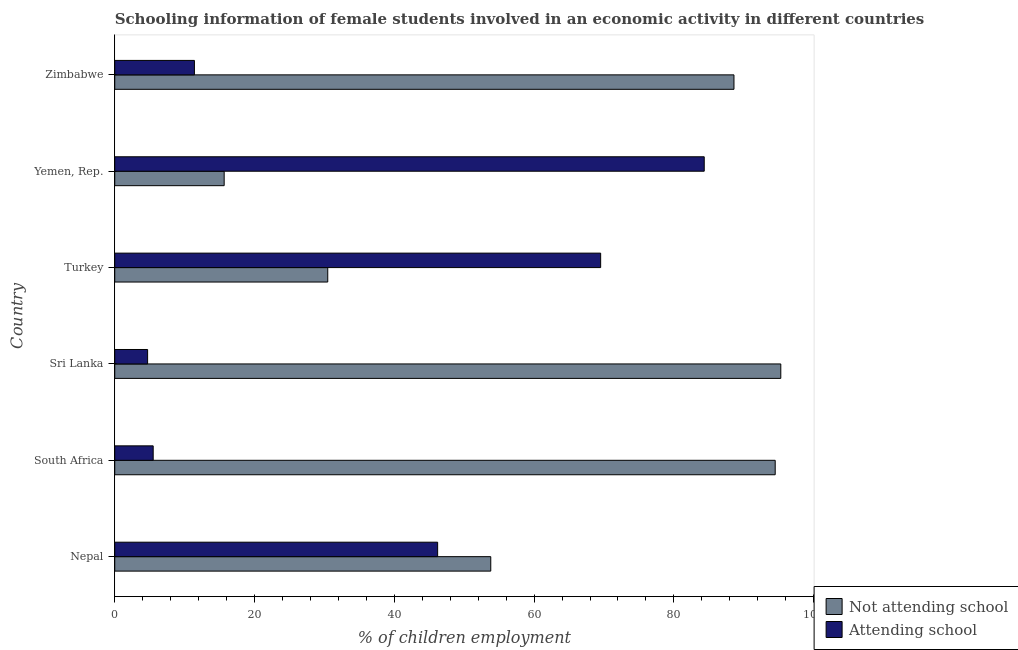Are the number of bars per tick equal to the number of legend labels?
Keep it short and to the point. Yes. How many bars are there on the 4th tick from the top?
Your response must be concise. 2. How many bars are there on the 3rd tick from the bottom?
Your answer should be very brief. 2. What is the label of the 2nd group of bars from the top?
Your response must be concise. Yemen, Rep. In how many cases, is the number of bars for a given country not equal to the number of legend labels?
Offer a very short reply. 0. What is the percentage of employed females who are attending school in Yemen, Rep.?
Your answer should be compact. 84.34. Across all countries, what is the maximum percentage of employed females who are attending school?
Offer a very short reply. 84.34. Across all countries, what is the minimum percentage of employed females who are not attending school?
Your answer should be very brief. 15.66. In which country was the percentage of employed females who are attending school maximum?
Provide a succinct answer. Yemen, Rep. In which country was the percentage of employed females who are not attending school minimum?
Give a very brief answer. Yemen, Rep. What is the total percentage of employed females who are not attending school in the graph?
Make the answer very short. 378.33. What is the difference between the percentage of employed females who are not attending school in Yemen, Rep. and that in Zimbabwe?
Offer a terse response. -72.94. What is the difference between the percentage of employed females who are attending school in Sri Lanka and the percentage of employed females who are not attending school in South Africa?
Ensure brevity in your answer.  -89.8. What is the average percentage of employed females who are attending school per country?
Keep it short and to the point. 36.95. What is the difference between the percentage of employed females who are not attending school and percentage of employed females who are attending school in Yemen, Rep.?
Provide a succinct answer. -68.69. In how many countries, is the percentage of employed females who are attending school greater than 32 %?
Keep it short and to the point. 3. What is the ratio of the percentage of employed females who are not attending school in Nepal to that in Yemen, Rep.?
Keep it short and to the point. 3.44. Is the difference between the percentage of employed females who are attending school in South Africa and Yemen, Rep. greater than the difference between the percentage of employed females who are not attending school in South Africa and Yemen, Rep.?
Keep it short and to the point. No. What is the difference between the highest and the lowest percentage of employed females who are attending school?
Your response must be concise. 79.64. In how many countries, is the percentage of employed females who are attending school greater than the average percentage of employed females who are attending school taken over all countries?
Keep it short and to the point. 3. What does the 2nd bar from the top in Nepal represents?
Ensure brevity in your answer.  Not attending school. What does the 1st bar from the bottom in South Africa represents?
Ensure brevity in your answer.  Not attending school. How many bars are there?
Keep it short and to the point. 12. Are all the bars in the graph horizontal?
Ensure brevity in your answer.  Yes. How many countries are there in the graph?
Your response must be concise. 6. What is the difference between two consecutive major ticks on the X-axis?
Offer a terse response. 20. Are the values on the major ticks of X-axis written in scientific E-notation?
Offer a terse response. No. Does the graph contain any zero values?
Ensure brevity in your answer.  No. How many legend labels are there?
Provide a succinct answer. 2. What is the title of the graph?
Your answer should be compact. Schooling information of female students involved in an economic activity in different countries. Does "External balance on goods" appear as one of the legend labels in the graph?
Your response must be concise. No. What is the label or title of the X-axis?
Make the answer very short. % of children employment. What is the label or title of the Y-axis?
Keep it short and to the point. Country. What is the % of children employment in Not attending school in Nepal?
Keep it short and to the point. 53.8. What is the % of children employment of Attending school in Nepal?
Keep it short and to the point. 46.2. What is the % of children employment in Not attending school in South Africa?
Ensure brevity in your answer.  94.5. What is the % of children employment of Attending school in South Africa?
Make the answer very short. 5.5. What is the % of children employment of Not attending school in Sri Lanka?
Keep it short and to the point. 95.3. What is the % of children employment of Attending school in Sri Lanka?
Offer a terse response. 4.7. What is the % of children employment of Not attending school in Turkey?
Provide a short and direct response. 30.48. What is the % of children employment of Attending school in Turkey?
Offer a very short reply. 69.52. What is the % of children employment of Not attending school in Yemen, Rep.?
Make the answer very short. 15.66. What is the % of children employment in Attending school in Yemen, Rep.?
Your response must be concise. 84.34. What is the % of children employment in Not attending school in Zimbabwe?
Ensure brevity in your answer.  88.6. What is the % of children employment of Attending school in Zimbabwe?
Provide a short and direct response. 11.4. Across all countries, what is the maximum % of children employment in Not attending school?
Your answer should be compact. 95.3. Across all countries, what is the maximum % of children employment in Attending school?
Provide a short and direct response. 84.34. Across all countries, what is the minimum % of children employment in Not attending school?
Your answer should be very brief. 15.66. Across all countries, what is the minimum % of children employment of Attending school?
Keep it short and to the point. 4.7. What is the total % of children employment in Not attending school in the graph?
Keep it short and to the point. 378.33. What is the total % of children employment of Attending school in the graph?
Your answer should be very brief. 221.67. What is the difference between the % of children employment of Not attending school in Nepal and that in South Africa?
Your response must be concise. -40.7. What is the difference between the % of children employment in Attending school in Nepal and that in South Africa?
Offer a terse response. 40.7. What is the difference between the % of children employment of Not attending school in Nepal and that in Sri Lanka?
Your answer should be very brief. -41.5. What is the difference between the % of children employment in Attending school in Nepal and that in Sri Lanka?
Your response must be concise. 41.5. What is the difference between the % of children employment of Not attending school in Nepal and that in Turkey?
Offer a very short reply. 23.32. What is the difference between the % of children employment in Attending school in Nepal and that in Turkey?
Provide a succinct answer. -23.32. What is the difference between the % of children employment of Not attending school in Nepal and that in Yemen, Rep.?
Make the answer very short. 38.14. What is the difference between the % of children employment in Attending school in Nepal and that in Yemen, Rep.?
Offer a very short reply. -38.15. What is the difference between the % of children employment in Not attending school in Nepal and that in Zimbabwe?
Provide a succinct answer. -34.8. What is the difference between the % of children employment in Attending school in Nepal and that in Zimbabwe?
Your answer should be very brief. 34.8. What is the difference between the % of children employment in Not attending school in South Africa and that in Sri Lanka?
Your answer should be compact. -0.8. What is the difference between the % of children employment of Attending school in South Africa and that in Sri Lanka?
Ensure brevity in your answer.  0.8. What is the difference between the % of children employment in Not attending school in South Africa and that in Turkey?
Ensure brevity in your answer.  64.02. What is the difference between the % of children employment of Attending school in South Africa and that in Turkey?
Ensure brevity in your answer.  -64.02. What is the difference between the % of children employment in Not attending school in South Africa and that in Yemen, Rep.?
Offer a terse response. 78.84. What is the difference between the % of children employment in Attending school in South Africa and that in Yemen, Rep.?
Give a very brief answer. -78.84. What is the difference between the % of children employment of Not attending school in South Africa and that in Zimbabwe?
Your answer should be very brief. 5.9. What is the difference between the % of children employment in Not attending school in Sri Lanka and that in Turkey?
Ensure brevity in your answer.  64.82. What is the difference between the % of children employment of Attending school in Sri Lanka and that in Turkey?
Your answer should be compact. -64.82. What is the difference between the % of children employment in Not attending school in Sri Lanka and that in Yemen, Rep.?
Offer a terse response. 79.64. What is the difference between the % of children employment in Attending school in Sri Lanka and that in Yemen, Rep.?
Ensure brevity in your answer.  -79.64. What is the difference between the % of children employment of Not attending school in Sri Lanka and that in Zimbabwe?
Give a very brief answer. 6.7. What is the difference between the % of children employment in Not attending school in Turkey and that in Yemen, Rep.?
Give a very brief answer. 14.82. What is the difference between the % of children employment of Attending school in Turkey and that in Yemen, Rep.?
Offer a very short reply. -14.82. What is the difference between the % of children employment in Not attending school in Turkey and that in Zimbabwe?
Ensure brevity in your answer.  -58.12. What is the difference between the % of children employment in Attending school in Turkey and that in Zimbabwe?
Offer a very short reply. 58.12. What is the difference between the % of children employment in Not attending school in Yemen, Rep. and that in Zimbabwe?
Offer a very short reply. -72.94. What is the difference between the % of children employment in Attending school in Yemen, Rep. and that in Zimbabwe?
Offer a terse response. 72.94. What is the difference between the % of children employment of Not attending school in Nepal and the % of children employment of Attending school in South Africa?
Offer a terse response. 48.3. What is the difference between the % of children employment of Not attending school in Nepal and the % of children employment of Attending school in Sri Lanka?
Give a very brief answer. 49.1. What is the difference between the % of children employment of Not attending school in Nepal and the % of children employment of Attending school in Turkey?
Your response must be concise. -15.72. What is the difference between the % of children employment in Not attending school in Nepal and the % of children employment in Attending school in Yemen, Rep.?
Offer a terse response. -30.55. What is the difference between the % of children employment in Not attending school in Nepal and the % of children employment in Attending school in Zimbabwe?
Your response must be concise. 42.4. What is the difference between the % of children employment of Not attending school in South Africa and the % of children employment of Attending school in Sri Lanka?
Ensure brevity in your answer.  89.8. What is the difference between the % of children employment of Not attending school in South Africa and the % of children employment of Attending school in Turkey?
Provide a short and direct response. 24.98. What is the difference between the % of children employment in Not attending school in South Africa and the % of children employment in Attending school in Yemen, Rep.?
Give a very brief answer. 10.15. What is the difference between the % of children employment of Not attending school in South Africa and the % of children employment of Attending school in Zimbabwe?
Offer a terse response. 83.1. What is the difference between the % of children employment of Not attending school in Sri Lanka and the % of children employment of Attending school in Turkey?
Give a very brief answer. 25.78. What is the difference between the % of children employment in Not attending school in Sri Lanka and the % of children employment in Attending school in Yemen, Rep.?
Offer a very short reply. 10.96. What is the difference between the % of children employment of Not attending school in Sri Lanka and the % of children employment of Attending school in Zimbabwe?
Your answer should be compact. 83.9. What is the difference between the % of children employment of Not attending school in Turkey and the % of children employment of Attending school in Yemen, Rep.?
Give a very brief answer. -53.87. What is the difference between the % of children employment of Not attending school in Turkey and the % of children employment of Attending school in Zimbabwe?
Provide a short and direct response. 19.08. What is the difference between the % of children employment in Not attending school in Yemen, Rep. and the % of children employment in Attending school in Zimbabwe?
Ensure brevity in your answer.  4.25. What is the average % of children employment in Not attending school per country?
Your answer should be very brief. 63.06. What is the average % of children employment of Attending school per country?
Offer a terse response. 36.94. What is the difference between the % of children employment in Not attending school and % of children employment in Attending school in South Africa?
Provide a succinct answer. 89. What is the difference between the % of children employment in Not attending school and % of children employment in Attending school in Sri Lanka?
Ensure brevity in your answer.  90.6. What is the difference between the % of children employment in Not attending school and % of children employment in Attending school in Turkey?
Give a very brief answer. -39.05. What is the difference between the % of children employment in Not attending school and % of children employment in Attending school in Yemen, Rep.?
Provide a succinct answer. -68.69. What is the difference between the % of children employment in Not attending school and % of children employment in Attending school in Zimbabwe?
Your response must be concise. 77.2. What is the ratio of the % of children employment in Not attending school in Nepal to that in South Africa?
Your answer should be very brief. 0.57. What is the ratio of the % of children employment in Attending school in Nepal to that in South Africa?
Keep it short and to the point. 8.4. What is the ratio of the % of children employment of Not attending school in Nepal to that in Sri Lanka?
Offer a very short reply. 0.56. What is the ratio of the % of children employment of Attending school in Nepal to that in Sri Lanka?
Provide a short and direct response. 9.83. What is the ratio of the % of children employment in Not attending school in Nepal to that in Turkey?
Ensure brevity in your answer.  1.77. What is the ratio of the % of children employment in Attending school in Nepal to that in Turkey?
Offer a very short reply. 0.66. What is the ratio of the % of children employment in Not attending school in Nepal to that in Yemen, Rep.?
Ensure brevity in your answer.  3.44. What is the ratio of the % of children employment in Attending school in Nepal to that in Yemen, Rep.?
Offer a terse response. 0.55. What is the ratio of the % of children employment of Not attending school in Nepal to that in Zimbabwe?
Your response must be concise. 0.61. What is the ratio of the % of children employment in Attending school in Nepal to that in Zimbabwe?
Your response must be concise. 4.05. What is the ratio of the % of children employment of Attending school in South Africa to that in Sri Lanka?
Your response must be concise. 1.17. What is the ratio of the % of children employment in Not attending school in South Africa to that in Turkey?
Offer a terse response. 3.1. What is the ratio of the % of children employment of Attending school in South Africa to that in Turkey?
Your answer should be very brief. 0.08. What is the ratio of the % of children employment in Not attending school in South Africa to that in Yemen, Rep.?
Provide a short and direct response. 6.04. What is the ratio of the % of children employment in Attending school in South Africa to that in Yemen, Rep.?
Your answer should be very brief. 0.07. What is the ratio of the % of children employment in Not attending school in South Africa to that in Zimbabwe?
Ensure brevity in your answer.  1.07. What is the ratio of the % of children employment in Attending school in South Africa to that in Zimbabwe?
Provide a short and direct response. 0.48. What is the ratio of the % of children employment of Not attending school in Sri Lanka to that in Turkey?
Your answer should be compact. 3.13. What is the ratio of the % of children employment of Attending school in Sri Lanka to that in Turkey?
Give a very brief answer. 0.07. What is the ratio of the % of children employment in Not attending school in Sri Lanka to that in Yemen, Rep.?
Your answer should be very brief. 6.09. What is the ratio of the % of children employment in Attending school in Sri Lanka to that in Yemen, Rep.?
Offer a terse response. 0.06. What is the ratio of the % of children employment in Not attending school in Sri Lanka to that in Zimbabwe?
Offer a terse response. 1.08. What is the ratio of the % of children employment in Attending school in Sri Lanka to that in Zimbabwe?
Offer a terse response. 0.41. What is the ratio of the % of children employment of Not attending school in Turkey to that in Yemen, Rep.?
Give a very brief answer. 1.95. What is the ratio of the % of children employment in Attending school in Turkey to that in Yemen, Rep.?
Make the answer very short. 0.82. What is the ratio of the % of children employment in Not attending school in Turkey to that in Zimbabwe?
Offer a very short reply. 0.34. What is the ratio of the % of children employment of Attending school in Turkey to that in Zimbabwe?
Make the answer very short. 6.1. What is the ratio of the % of children employment in Not attending school in Yemen, Rep. to that in Zimbabwe?
Offer a very short reply. 0.18. What is the ratio of the % of children employment of Attending school in Yemen, Rep. to that in Zimbabwe?
Keep it short and to the point. 7.4. What is the difference between the highest and the second highest % of children employment of Attending school?
Keep it short and to the point. 14.82. What is the difference between the highest and the lowest % of children employment in Not attending school?
Offer a terse response. 79.64. What is the difference between the highest and the lowest % of children employment of Attending school?
Your answer should be compact. 79.64. 